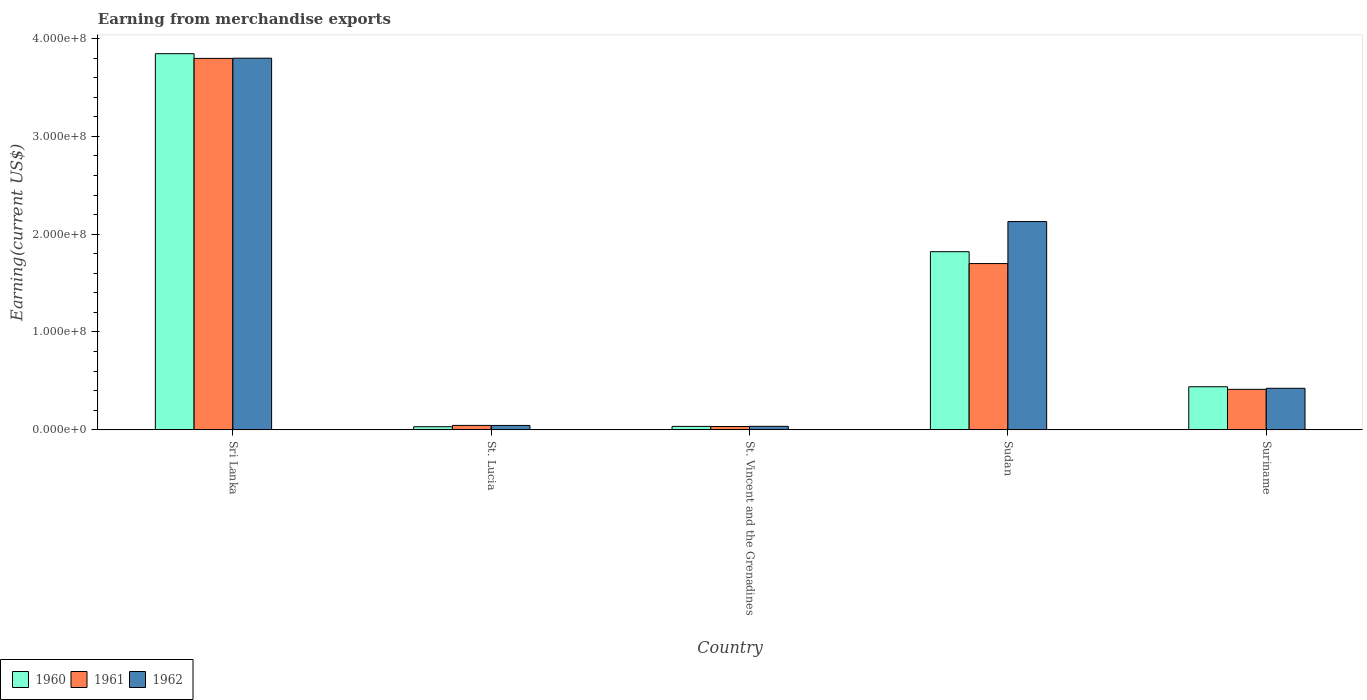Are the number of bars per tick equal to the number of legend labels?
Give a very brief answer. Yes. What is the label of the 1st group of bars from the left?
Your answer should be very brief. Sri Lanka. What is the amount earned from merchandise exports in 1962 in St. Lucia?
Provide a succinct answer. 4.46e+06. Across all countries, what is the maximum amount earned from merchandise exports in 1961?
Give a very brief answer. 3.80e+08. Across all countries, what is the minimum amount earned from merchandise exports in 1961?
Provide a succinct answer. 3.37e+06. In which country was the amount earned from merchandise exports in 1961 maximum?
Your answer should be compact. Sri Lanka. In which country was the amount earned from merchandise exports in 1962 minimum?
Your response must be concise. St. Vincent and the Grenadines. What is the total amount earned from merchandise exports in 1962 in the graph?
Give a very brief answer. 6.43e+08. What is the difference between the amount earned from merchandise exports in 1960 in St. Lucia and that in St. Vincent and the Grenadines?
Your answer should be compact. -3.35e+05. What is the difference between the amount earned from merchandise exports in 1961 in Suriname and the amount earned from merchandise exports in 1962 in Sudan?
Offer a very short reply. -1.72e+08. What is the average amount earned from merchandise exports in 1962 per country?
Offer a terse response. 1.29e+08. What is the difference between the amount earned from merchandise exports of/in 1961 and amount earned from merchandise exports of/in 1962 in St. Vincent and the Grenadines?
Provide a short and direct response. -1.87e+05. In how many countries, is the amount earned from merchandise exports in 1960 greater than 220000000 US$?
Your answer should be very brief. 1. What is the ratio of the amount earned from merchandise exports in 1960 in Sri Lanka to that in Suriname?
Your answer should be compact. 8.74. What is the difference between the highest and the second highest amount earned from merchandise exports in 1960?
Provide a succinct answer. 3.40e+08. What is the difference between the highest and the lowest amount earned from merchandise exports in 1960?
Offer a terse response. 3.81e+08. Is the sum of the amount earned from merchandise exports in 1962 in St. Vincent and the Grenadines and Sudan greater than the maximum amount earned from merchandise exports in 1960 across all countries?
Provide a succinct answer. No. Is it the case that in every country, the sum of the amount earned from merchandise exports in 1961 and amount earned from merchandise exports in 1960 is greater than the amount earned from merchandise exports in 1962?
Ensure brevity in your answer.  Yes. How many bars are there?
Ensure brevity in your answer.  15. Are all the bars in the graph horizontal?
Provide a succinct answer. No. What is the difference between two consecutive major ticks on the Y-axis?
Ensure brevity in your answer.  1.00e+08. Are the values on the major ticks of Y-axis written in scientific E-notation?
Provide a succinct answer. Yes. Does the graph contain any zero values?
Provide a short and direct response. No. Does the graph contain grids?
Ensure brevity in your answer.  No. How many legend labels are there?
Ensure brevity in your answer.  3. How are the legend labels stacked?
Ensure brevity in your answer.  Horizontal. What is the title of the graph?
Provide a succinct answer. Earning from merchandise exports. What is the label or title of the X-axis?
Offer a very short reply. Country. What is the label or title of the Y-axis?
Give a very brief answer. Earning(current US$). What is the Earning(current US$) of 1960 in Sri Lanka?
Give a very brief answer. 3.85e+08. What is the Earning(current US$) in 1961 in Sri Lanka?
Your answer should be compact. 3.80e+08. What is the Earning(current US$) of 1962 in Sri Lanka?
Your response must be concise. 3.80e+08. What is the Earning(current US$) of 1960 in St. Lucia?
Keep it short and to the point. 3.15e+06. What is the Earning(current US$) of 1961 in St. Lucia?
Make the answer very short. 4.51e+06. What is the Earning(current US$) of 1962 in St. Lucia?
Your response must be concise. 4.46e+06. What is the Earning(current US$) of 1960 in St. Vincent and the Grenadines?
Provide a succinct answer. 3.48e+06. What is the Earning(current US$) of 1961 in St. Vincent and the Grenadines?
Your response must be concise. 3.37e+06. What is the Earning(current US$) in 1962 in St. Vincent and the Grenadines?
Ensure brevity in your answer.  3.56e+06. What is the Earning(current US$) of 1960 in Sudan?
Keep it short and to the point. 1.82e+08. What is the Earning(current US$) in 1961 in Sudan?
Offer a very short reply. 1.70e+08. What is the Earning(current US$) in 1962 in Sudan?
Your answer should be very brief. 2.13e+08. What is the Earning(current US$) of 1960 in Suriname?
Your answer should be compact. 4.40e+07. What is the Earning(current US$) in 1961 in Suriname?
Keep it short and to the point. 4.14e+07. What is the Earning(current US$) in 1962 in Suriname?
Provide a short and direct response. 4.24e+07. Across all countries, what is the maximum Earning(current US$) in 1960?
Provide a succinct answer. 3.85e+08. Across all countries, what is the maximum Earning(current US$) of 1961?
Your answer should be very brief. 3.80e+08. Across all countries, what is the maximum Earning(current US$) in 1962?
Provide a short and direct response. 3.80e+08. Across all countries, what is the minimum Earning(current US$) in 1960?
Give a very brief answer. 3.15e+06. Across all countries, what is the minimum Earning(current US$) of 1961?
Give a very brief answer. 3.37e+06. Across all countries, what is the minimum Earning(current US$) of 1962?
Your response must be concise. 3.56e+06. What is the total Earning(current US$) in 1960 in the graph?
Offer a very short reply. 6.17e+08. What is the total Earning(current US$) of 1961 in the graph?
Give a very brief answer. 5.99e+08. What is the total Earning(current US$) of 1962 in the graph?
Ensure brevity in your answer.  6.43e+08. What is the difference between the Earning(current US$) in 1960 in Sri Lanka and that in St. Lucia?
Make the answer very short. 3.81e+08. What is the difference between the Earning(current US$) in 1961 in Sri Lanka and that in St. Lucia?
Ensure brevity in your answer.  3.75e+08. What is the difference between the Earning(current US$) of 1962 in Sri Lanka and that in St. Lucia?
Your answer should be very brief. 3.75e+08. What is the difference between the Earning(current US$) of 1960 in Sri Lanka and that in St. Vincent and the Grenadines?
Ensure brevity in your answer.  3.81e+08. What is the difference between the Earning(current US$) in 1961 in Sri Lanka and that in St. Vincent and the Grenadines?
Provide a succinct answer. 3.76e+08. What is the difference between the Earning(current US$) in 1962 in Sri Lanka and that in St. Vincent and the Grenadines?
Offer a terse response. 3.76e+08. What is the difference between the Earning(current US$) of 1960 in Sri Lanka and that in Sudan?
Keep it short and to the point. 2.02e+08. What is the difference between the Earning(current US$) in 1961 in Sri Lanka and that in Sudan?
Offer a very short reply. 2.10e+08. What is the difference between the Earning(current US$) in 1962 in Sri Lanka and that in Sudan?
Your answer should be very brief. 1.67e+08. What is the difference between the Earning(current US$) of 1960 in Sri Lanka and that in Suriname?
Provide a succinct answer. 3.40e+08. What is the difference between the Earning(current US$) in 1961 in Sri Lanka and that in Suriname?
Provide a succinct answer. 3.38e+08. What is the difference between the Earning(current US$) in 1962 in Sri Lanka and that in Suriname?
Offer a very short reply. 3.37e+08. What is the difference between the Earning(current US$) in 1960 in St. Lucia and that in St. Vincent and the Grenadines?
Your response must be concise. -3.35e+05. What is the difference between the Earning(current US$) of 1961 in St. Lucia and that in St. Vincent and the Grenadines?
Ensure brevity in your answer.  1.14e+06. What is the difference between the Earning(current US$) in 1962 in St. Lucia and that in St. Vincent and the Grenadines?
Give a very brief answer. 9.00e+05. What is the difference between the Earning(current US$) of 1960 in St. Lucia and that in Sudan?
Offer a very short reply. -1.79e+08. What is the difference between the Earning(current US$) in 1961 in St. Lucia and that in Sudan?
Ensure brevity in your answer.  -1.65e+08. What is the difference between the Earning(current US$) in 1962 in St. Lucia and that in Sudan?
Provide a succinct answer. -2.08e+08. What is the difference between the Earning(current US$) of 1960 in St. Lucia and that in Suriname?
Your answer should be very brief. -4.09e+07. What is the difference between the Earning(current US$) of 1961 in St. Lucia and that in Suriname?
Provide a succinct answer. -3.68e+07. What is the difference between the Earning(current US$) of 1962 in St. Lucia and that in Suriname?
Your answer should be very brief. -3.80e+07. What is the difference between the Earning(current US$) of 1960 in St. Vincent and the Grenadines and that in Sudan?
Your answer should be very brief. -1.79e+08. What is the difference between the Earning(current US$) in 1961 in St. Vincent and the Grenadines and that in Sudan?
Offer a terse response. -1.67e+08. What is the difference between the Earning(current US$) in 1962 in St. Vincent and the Grenadines and that in Sudan?
Provide a succinct answer. -2.09e+08. What is the difference between the Earning(current US$) in 1960 in St. Vincent and the Grenadines and that in Suriname?
Ensure brevity in your answer.  -4.05e+07. What is the difference between the Earning(current US$) of 1961 in St. Vincent and the Grenadines and that in Suriname?
Offer a terse response. -3.80e+07. What is the difference between the Earning(current US$) in 1962 in St. Vincent and the Grenadines and that in Suriname?
Keep it short and to the point. -3.89e+07. What is the difference between the Earning(current US$) in 1960 in Sudan and that in Suriname?
Ensure brevity in your answer.  1.38e+08. What is the difference between the Earning(current US$) in 1961 in Sudan and that in Suriname?
Ensure brevity in your answer.  1.29e+08. What is the difference between the Earning(current US$) in 1962 in Sudan and that in Suriname?
Keep it short and to the point. 1.70e+08. What is the difference between the Earning(current US$) of 1960 in Sri Lanka and the Earning(current US$) of 1961 in St. Lucia?
Ensure brevity in your answer.  3.80e+08. What is the difference between the Earning(current US$) in 1960 in Sri Lanka and the Earning(current US$) in 1962 in St. Lucia?
Your answer should be very brief. 3.80e+08. What is the difference between the Earning(current US$) in 1961 in Sri Lanka and the Earning(current US$) in 1962 in St. Lucia?
Your answer should be compact. 3.75e+08. What is the difference between the Earning(current US$) in 1960 in Sri Lanka and the Earning(current US$) in 1961 in St. Vincent and the Grenadines?
Offer a terse response. 3.81e+08. What is the difference between the Earning(current US$) in 1960 in Sri Lanka and the Earning(current US$) in 1962 in St. Vincent and the Grenadines?
Provide a succinct answer. 3.81e+08. What is the difference between the Earning(current US$) of 1961 in Sri Lanka and the Earning(current US$) of 1962 in St. Vincent and the Grenadines?
Your answer should be compact. 3.76e+08. What is the difference between the Earning(current US$) in 1960 in Sri Lanka and the Earning(current US$) in 1961 in Sudan?
Give a very brief answer. 2.15e+08. What is the difference between the Earning(current US$) in 1960 in Sri Lanka and the Earning(current US$) in 1962 in Sudan?
Your answer should be compact. 1.72e+08. What is the difference between the Earning(current US$) of 1961 in Sri Lanka and the Earning(current US$) of 1962 in Sudan?
Make the answer very short. 1.67e+08. What is the difference between the Earning(current US$) in 1960 in Sri Lanka and the Earning(current US$) in 1961 in Suriname?
Your answer should be compact. 3.43e+08. What is the difference between the Earning(current US$) of 1960 in Sri Lanka and the Earning(current US$) of 1962 in Suriname?
Offer a very short reply. 3.42e+08. What is the difference between the Earning(current US$) of 1961 in Sri Lanka and the Earning(current US$) of 1962 in Suriname?
Ensure brevity in your answer.  3.37e+08. What is the difference between the Earning(current US$) in 1960 in St. Lucia and the Earning(current US$) in 1961 in St. Vincent and the Grenadines?
Provide a succinct answer. -2.23e+05. What is the difference between the Earning(current US$) of 1960 in St. Lucia and the Earning(current US$) of 1962 in St. Vincent and the Grenadines?
Keep it short and to the point. -4.11e+05. What is the difference between the Earning(current US$) of 1961 in St. Lucia and the Earning(current US$) of 1962 in St. Vincent and the Grenadines?
Offer a terse response. 9.56e+05. What is the difference between the Earning(current US$) in 1960 in St. Lucia and the Earning(current US$) in 1961 in Sudan?
Provide a succinct answer. -1.67e+08. What is the difference between the Earning(current US$) in 1960 in St. Lucia and the Earning(current US$) in 1962 in Sudan?
Ensure brevity in your answer.  -2.10e+08. What is the difference between the Earning(current US$) of 1961 in St. Lucia and the Earning(current US$) of 1962 in Sudan?
Give a very brief answer. -2.08e+08. What is the difference between the Earning(current US$) in 1960 in St. Lucia and the Earning(current US$) in 1961 in Suriname?
Provide a succinct answer. -3.82e+07. What is the difference between the Earning(current US$) of 1960 in St. Lucia and the Earning(current US$) of 1962 in Suriname?
Offer a very short reply. -3.93e+07. What is the difference between the Earning(current US$) in 1961 in St. Lucia and the Earning(current US$) in 1962 in Suriname?
Offer a terse response. -3.79e+07. What is the difference between the Earning(current US$) in 1960 in St. Vincent and the Grenadines and the Earning(current US$) in 1961 in Sudan?
Give a very brief answer. -1.66e+08. What is the difference between the Earning(current US$) of 1960 in St. Vincent and the Grenadines and the Earning(current US$) of 1962 in Sudan?
Provide a short and direct response. -2.09e+08. What is the difference between the Earning(current US$) of 1961 in St. Vincent and the Grenadines and the Earning(current US$) of 1962 in Sudan?
Make the answer very short. -2.10e+08. What is the difference between the Earning(current US$) of 1960 in St. Vincent and the Grenadines and the Earning(current US$) of 1961 in Suriname?
Provide a short and direct response. -3.79e+07. What is the difference between the Earning(current US$) of 1960 in St. Vincent and the Grenadines and the Earning(current US$) of 1962 in Suriname?
Ensure brevity in your answer.  -3.89e+07. What is the difference between the Earning(current US$) in 1961 in St. Vincent and the Grenadines and the Earning(current US$) in 1962 in Suriname?
Offer a terse response. -3.91e+07. What is the difference between the Earning(current US$) in 1960 in Sudan and the Earning(current US$) in 1961 in Suriname?
Keep it short and to the point. 1.41e+08. What is the difference between the Earning(current US$) in 1960 in Sudan and the Earning(current US$) in 1962 in Suriname?
Keep it short and to the point. 1.40e+08. What is the difference between the Earning(current US$) of 1961 in Sudan and the Earning(current US$) of 1962 in Suriname?
Ensure brevity in your answer.  1.28e+08. What is the average Earning(current US$) of 1960 per country?
Your answer should be very brief. 1.23e+08. What is the average Earning(current US$) in 1961 per country?
Provide a succinct answer. 1.20e+08. What is the average Earning(current US$) in 1962 per country?
Offer a very short reply. 1.29e+08. What is the difference between the Earning(current US$) in 1960 and Earning(current US$) in 1961 in Sri Lanka?
Offer a terse response. 4.83e+06. What is the difference between the Earning(current US$) of 1960 and Earning(current US$) of 1962 in Sri Lanka?
Make the answer very short. 4.62e+06. What is the difference between the Earning(current US$) in 1960 and Earning(current US$) in 1961 in St. Lucia?
Offer a very short reply. -1.37e+06. What is the difference between the Earning(current US$) of 1960 and Earning(current US$) of 1962 in St. Lucia?
Your answer should be very brief. -1.31e+06. What is the difference between the Earning(current US$) of 1961 and Earning(current US$) of 1962 in St. Lucia?
Your answer should be compact. 5.54e+04. What is the difference between the Earning(current US$) in 1960 and Earning(current US$) in 1961 in St. Vincent and the Grenadines?
Ensure brevity in your answer.  1.12e+05. What is the difference between the Earning(current US$) of 1960 and Earning(current US$) of 1962 in St. Vincent and the Grenadines?
Give a very brief answer. -7.52e+04. What is the difference between the Earning(current US$) of 1961 and Earning(current US$) of 1962 in St. Vincent and the Grenadines?
Ensure brevity in your answer.  -1.87e+05. What is the difference between the Earning(current US$) in 1960 and Earning(current US$) in 1961 in Sudan?
Offer a very short reply. 1.21e+07. What is the difference between the Earning(current US$) of 1960 and Earning(current US$) of 1962 in Sudan?
Make the answer very short. -3.08e+07. What is the difference between the Earning(current US$) in 1961 and Earning(current US$) in 1962 in Sudan?
Your answer should be compact. -4.30e+07. What is the difference between the Earning(current US$) of 1960 and Earning(current US$) of 1961 in Suriname?
Offer a terse response. 2.65e+06. What is the difference between the Earning(current US$) in 1960 and Earning(current US$) in 1962 in Suriname?
Offer a very short reply. 1.59e+06. What is the difference between the Earning(current US$) of 1961 and Earning(current US$) of 1962 in Suriname?
Offer a very short reply. -1.06e+06. What is the ratio of the Earning(current US$) of 1960 in Sri Lanka to that in St. Lucia?
Your answer should be very brief. 122.18. What is the ratio of the Earning(current US$) of 1961 in Sri Lanka to that in St. Lucia?
Provide a short and direct response. 84.13. What is the ratio of the Earning(current US$) of 1962 in Sri Lanka to that in St. Lucia?
Your answer should be very brief. 85.22. What is the ratio of the Earning(current US$) in 1960 in Sri Lanka to that in St. Vincent and the Grenadines?
Make the answer very short. 110.41. What is the ratio of the Earning(current US$) in 1961 in Sri Lanka to that in St. Vincent and the Grenadines?
Provide a succinct answer. 112.65. What is the ratio of the Earning(current US$) in 1962 in Sri Lanka to that in St. Vincent and the Grenadines?
Provide a short and direct response. 106.78. What is the ratio of the Earning(current US$) of 1960 in Sri Lanka to that in Sudan?
Your answer should be very brief. 2.11. What is the ratio of the Earning(current US$) of 1961 in Sri Lanka to that in Sudan?
Make the answer very short. 2.23. What is the ratio of the Earning(current US$) of 1962 in Sri Lanka to that in Sudan?
Ensure brevity in your answer.  1.78. What is the ratio of the Earning(current US$) of 1960 in Sri Lanka to that in Suriname?
Ensure brevity in your answer.  8.74. What is the ratio of the Earning(current US$) of 1961 in Sri Lanka to that in Suriname?
Offer a terse response. 9.18. What is the ratio of the Earning(current US$) in 1962 in Sri Lanka to that in Suriname?
Offer a very short reply. 8.96. What is the ratio of the Earning(current US$) of 1960 in St. Lucia to that in St. Vincent and the Grenadines?
Ensure brevity in your answer.  0.9. What is the ratio of the Earning(current US$) in 1961 in St. Lucia to that in St. Vincent and the Grenadines?
Make the answer very short. 1.34. What is the ratio of the Earning(current US$) in 1962 in St. Lucia to that in St. Vincent and the Grenadines?
Provide a succinct answer. 1.25. What is the ratio of the Earning(current US$) of 1960 in St. Lucia to that in Sudan?
Provide a short and direct response. 0.02. What is the ratio of the Earning(current US$) of 1961 in St. Lucia to that in Sudan?
Your response must be concise. 0.03. What is the ratio of the Earning(current US$) of 1962 in St. Lucia to that in Sudan?
Provide a succinct answer. 0.02. What is the ratio of the Earning(current US$) in 1960 in St. Lucia to that in Suriname?
Give a very brief answer. 0.07. What is the ratio of the Earning(current US$) in 1961 in St. Lucia to that in Suriname?
Offer a very short reply. 0.11. What is the ratio of the Earning(current US$) in 1962 in St. Lucia to that in Suriname?
Ensure brevity in your answer.  0.11. What is the ratio of the Earning(current US$) in 1960 in St. Vincent and the Grenadines to that in Sudan?
Ensure brevity in your answer.  0.02. What is the ratio of the Earning(current US$) in 1961 in St. Vincent and the Grenadines to that in Sudan?
Your answer should be very brief. 0.02. What is the ratio of the Earning(current US$) of 1962 in St. Vincent and the Grenadines to that in Sudan?
Keep it short and to the point. 0.02. What is the ratio of the Earning(current US$) in 1960 in St. Vincent and the Grenadines to that in Suriname?
Provide a short and direct response. 0.08. What is the ratio of the Earning(current US$) in 1961 in St. Vincent and the Grenadines to that in Suriname?
Ensure brevity in your answer.  0.08. What is the ratio of the Earning(current US$) of 1962 in St. Vincent and the Grenadines to that in Suriname?
Make the answer very short. 0.08. What is the ratio of the Earning(current US$) in 1960 in Sudan to that in Suriname?
Provide a succinct answer. 4.14. What is the ratio of the Earning(current US$) of 1961 in Sudan to that in Suriname?
Offer a very short reply. 4.11. What is the ratio of the Earning(current US$) in 1962 in Sudan to that in Suriname?
Make the answer very short. 5.02. What is the difference between the highest and the second highest Earning(current US$) in 1960?
Keep it short and to the point. 2.02e+08. What is the difference between the highest and the second highest Earning(current US$) of 1961?
Offer a terse response. 2.10e+08. What is the difference between the highest and the second highest Earning(current US$) in 1962?
Your answer should be very brief. 1.67e+08. What is the difference between the highest and the lowest Earning(current US$) of 1960?
Ensure brevity in your answer.  3.81e+08. What is the difference between the highest and the lowest Earning(current US$) of 1961?
Offer a very short reply. 3.76e+08. What is the difference between the highest and the lowest Earning(current US$) in 1962?
Your answer should be very brief. 3.76e+08. 